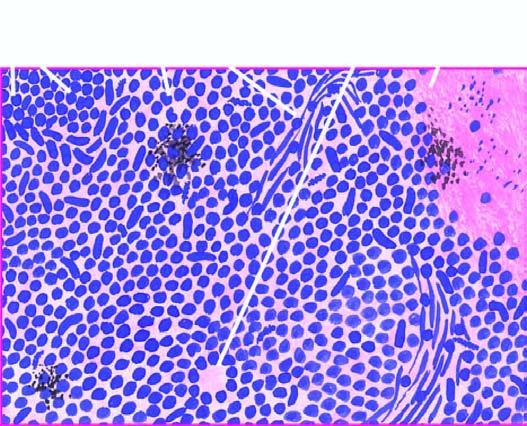what are arranged in sheets, cords or aggregates and at places form pseudorosettes?
Answer the question using a single word or phrase. Tumour cells 